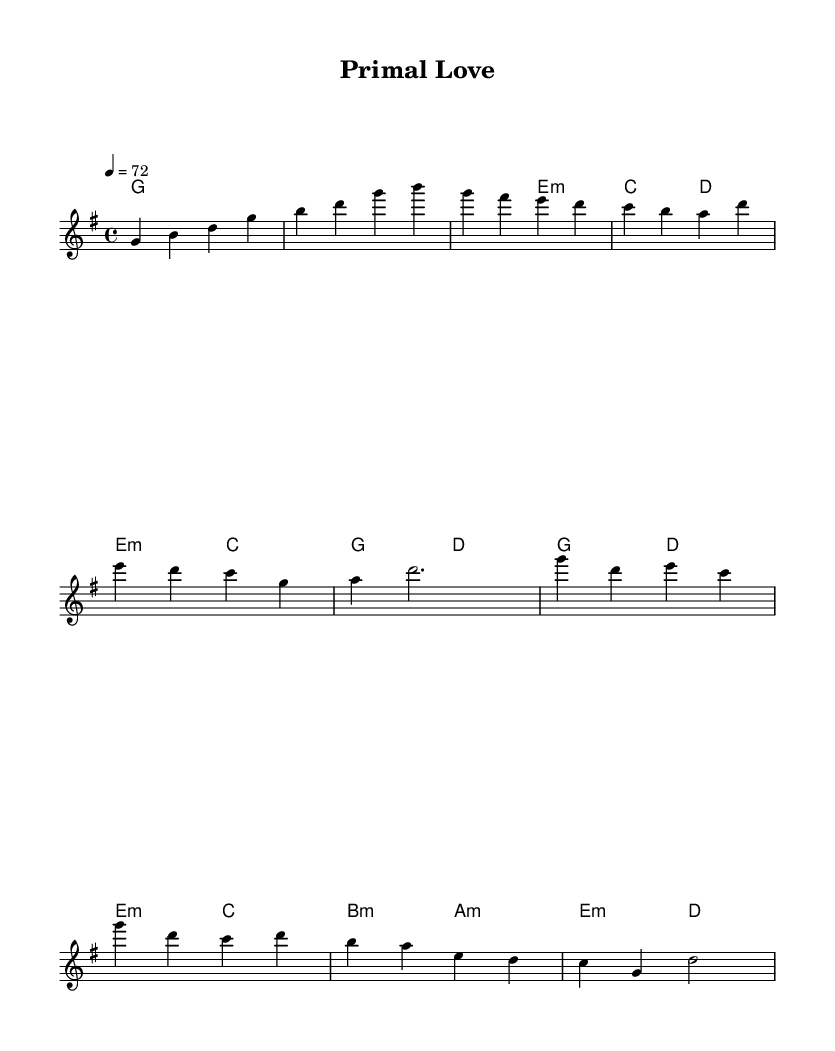What is the key signature of this music? The key signature is G major, which has one sharp (F#). You can determine the key by looking at the key signature indicated at the beginning of the sheet music.
Answer: G major What is the time signature of this music? The time signature is 4/4, which indicates that there are four beats in each measure, and the quarter note gets one beat. This can be identified by looking at the time signature notated at the beginning of the score.
Answer: 4/4 What is the tempo marking for this music? The tempo marking is 72 beats per minute, indicated by the metronome marking "4 = 72". It tells the performer to play at this speed. The tempo is presented at the beginning of the sheet music.
Answer: 72 What chords are used in the chorus section? The chords used in the chorus are G, D, E minor, and C. By examining the harmonies section along with the specific measures where the chorus is indicated, you can identify the corresponding chords that align with those measures.
Answer: G, D, E minor, C How many measures are in the bridge section? There are two measures in the bridge section, which can be observed by counting the number of measures indicated in the written music for that section. This section is marked with the word "Bridge."
Answer: 2 Which section contains the line "Primal Love"? The title "Primal Love" appears at the beginning of the sheet music, indicating the piece as a whole. This title is not found in the actual musical content but serves as an identifier for the entire composition.
Answer: Intro 